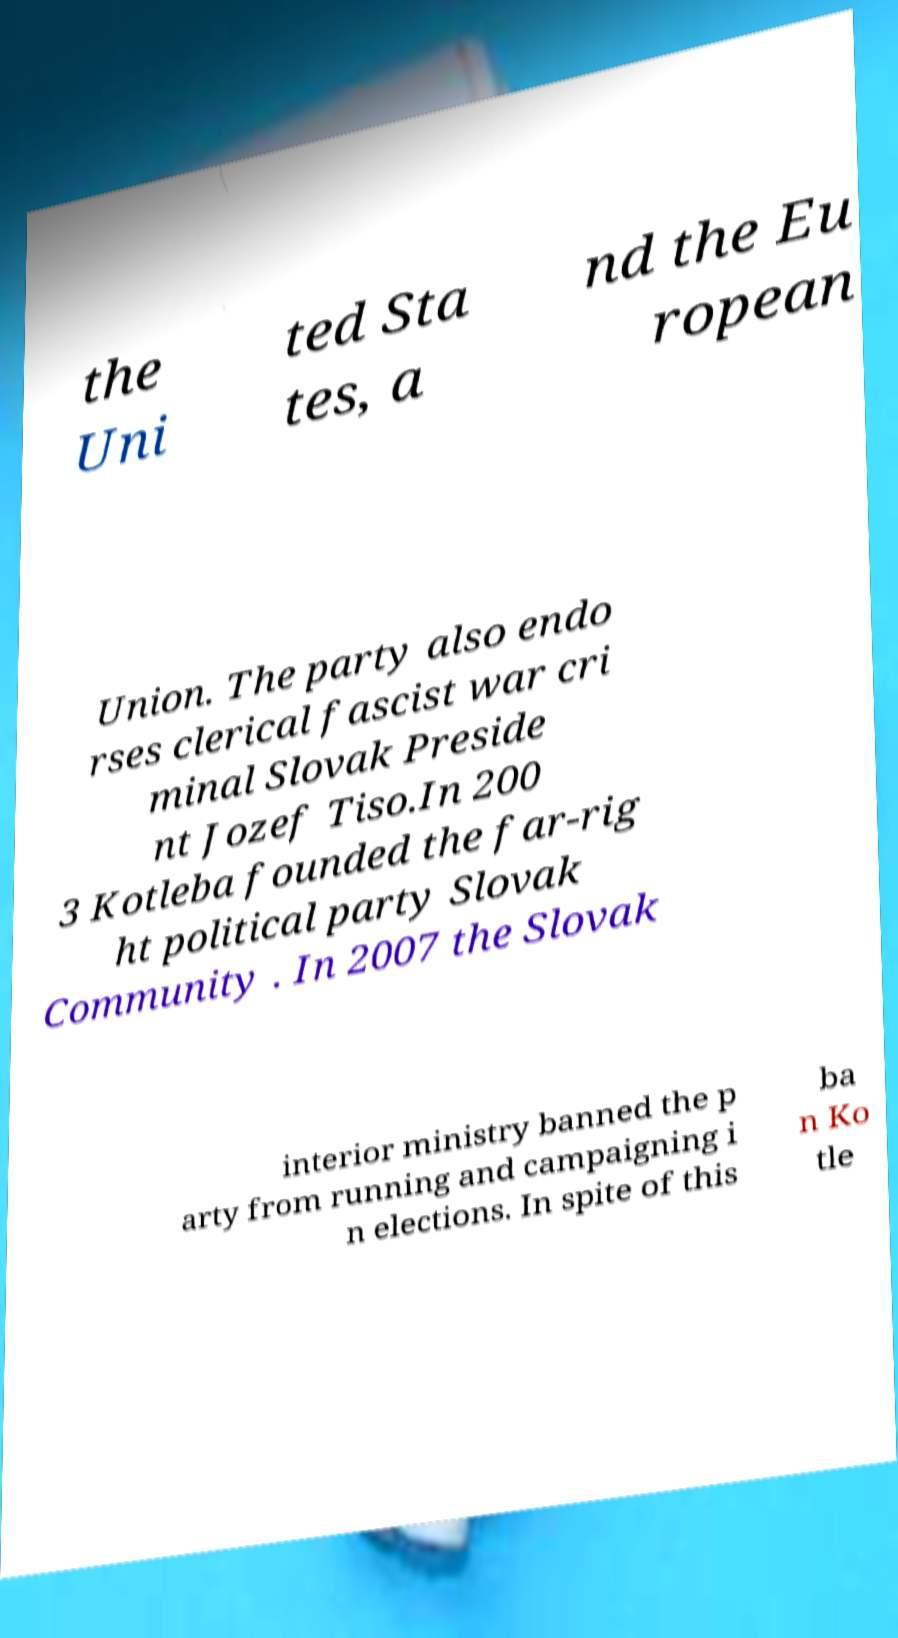Please identify and transcribe the text found in this image. the Uni ted Sta tes, a nd the Eu ropean Union. The party also endo rses clerical fascist war cri minal Slovak Preside nt Jozef Tiso.In 200 3 Kotleba founded the far-rig ht political party Slovak Community . In 2007 the Slovak interior ministry banned the p arty from running and campaigning i n elections. In spite of this ba n Ko tle 